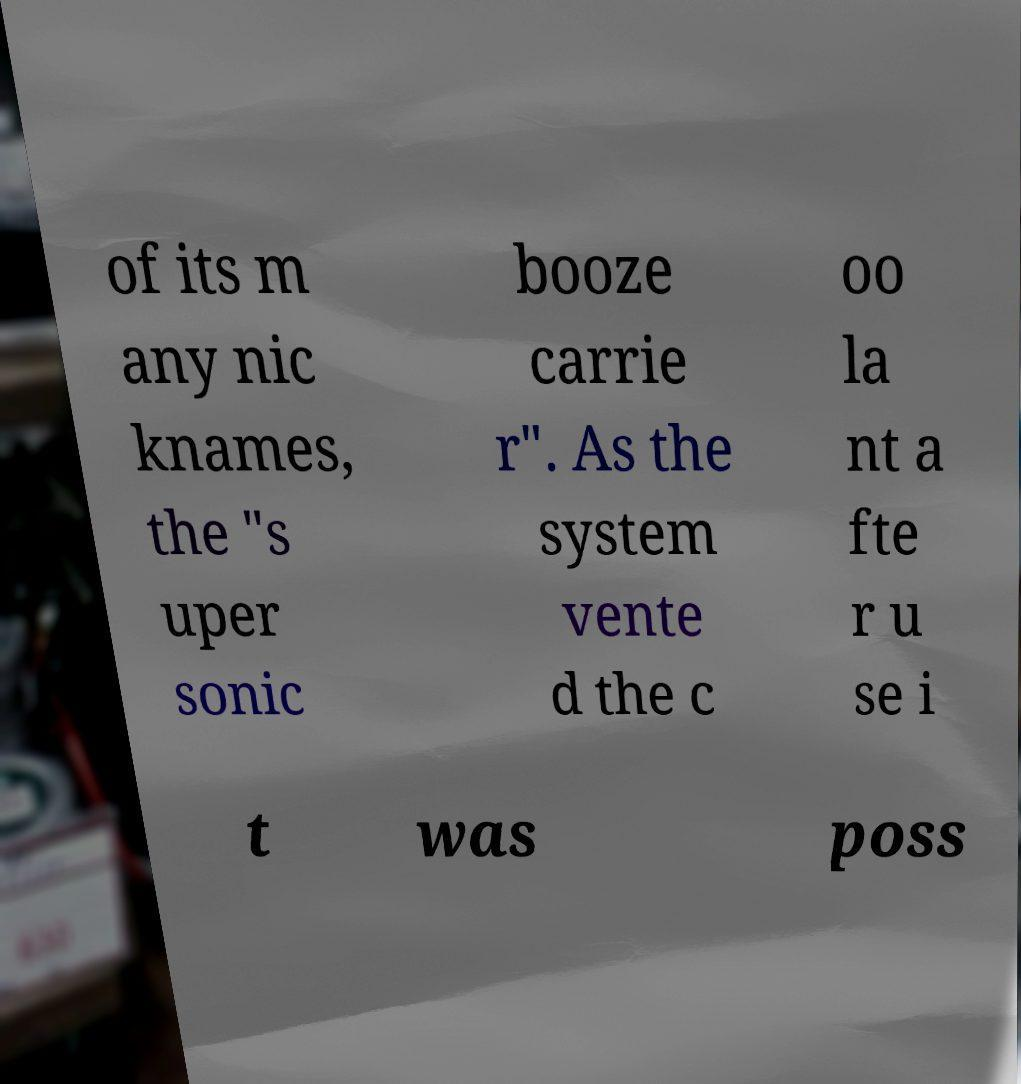Please identify and transcribe the text found in this image. of its m any nic knames, the "s uper sonic booze carrie r". As the system vente d the c oo la nt a fte r u se i t was poss 